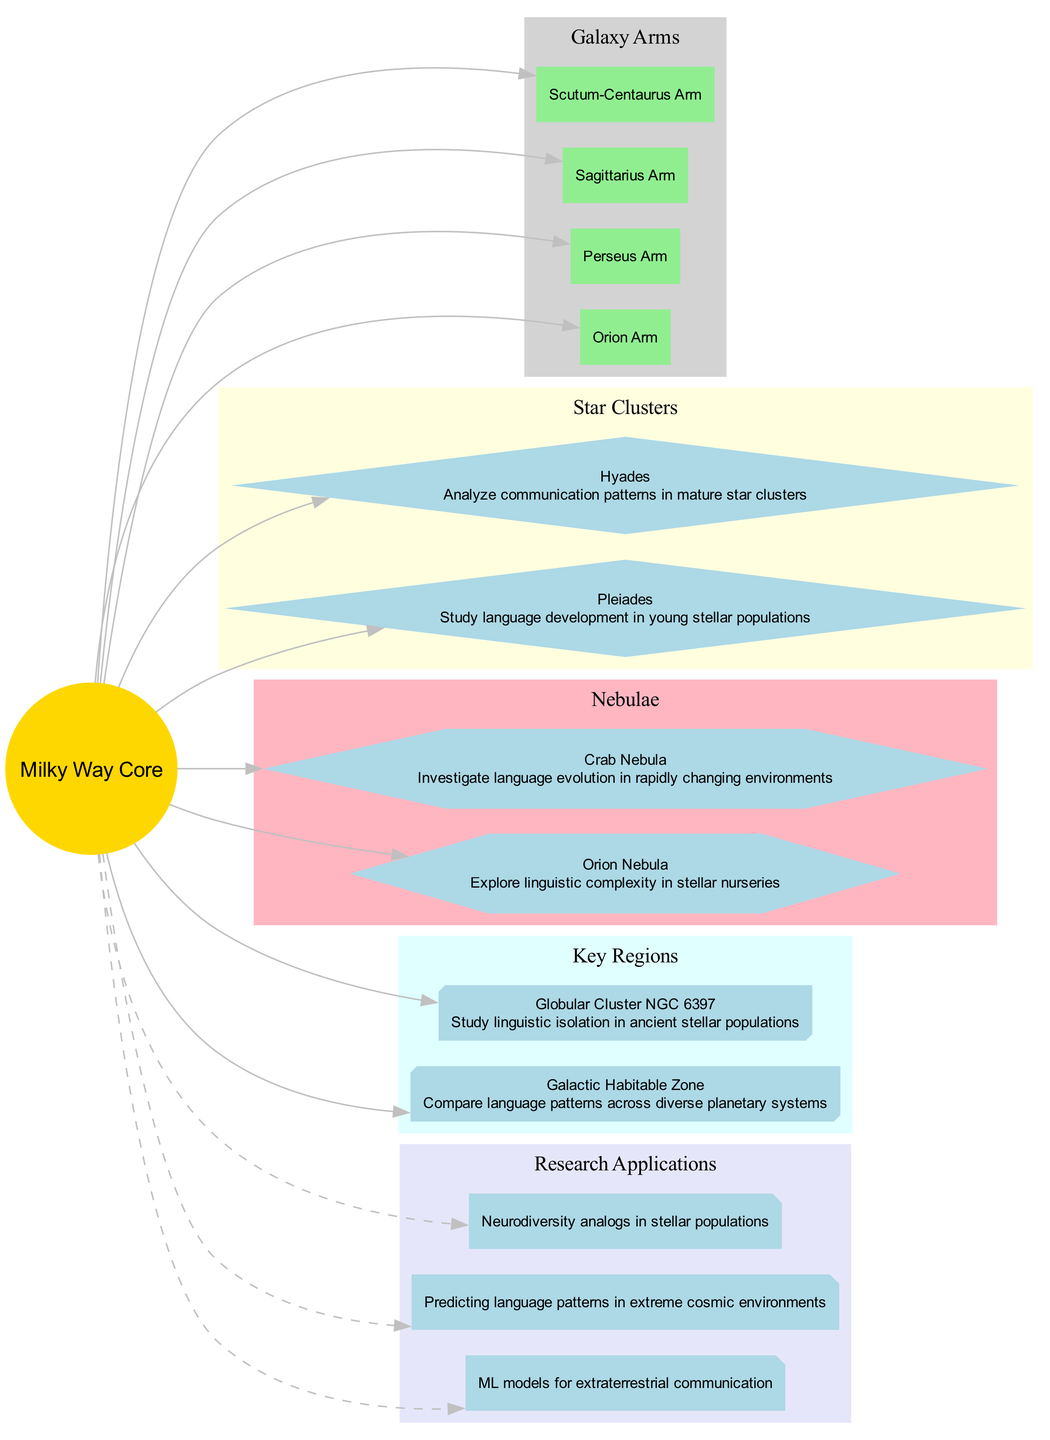What is the core of the Milky Way Galaxy? The core of the Milky Way Galaxy is labeled as "Milky Way Core" in the diagram, indicating it as the central part of the galaxy.
Answer: Milky Way Core How many star clusters are shown in the diagram? The diagram contains two star clusters: Pleiades and Hyades, which can be counted in the star clusters section.
Answer: 2 What major arm is labeled as "Orion Arm"? The label "Orion Arm" is mentioned in the arms section of the diagram, indicating its presence as one of the galaxy’s arms.
Answer: Orion Arm What is the annotation provided for the Orion Nebula? In the diagram, the Orion Nebula has the annotation "Explore linguistic complexity in stellar nurseries," which can be found next to its name.
Answer: Explore linguistic complexity in stellar nurseries Which key region is focused on linguistic isolation in ancient stellar populations? The key region named "Globular Cluster NGC 6397" in the diagram has the annotation addressing linguistic isolation in ancient stellar populations.
Answer: Globular Cluster NGC 6397 What research application involves ML models for extraterrestrial communication? The diagram includes the research application "ML models for extraterrestrial communication," which can be found in the research applications section.
Answer: ML models for extraterrestrial communication Which nebula is associated with language evolution in rapidly changing environments? The annotation next to the Crab Nebula states "Investigate language evolution in rapidly changing environments," indicating its specific research focus.
Answer: Investigate language evolution in rapidly changing environments What is annotated for the key region Galactic Habitable Zone? The Galactic Habitable Zone in the diagram is annotated with "Compare language patterns across diverse planetary systems," translating its implication for research purposes.
Answer: Compare language patterns across diverse planetary systems What type of star cluster is the Pleiades categorized as? The Pleiades is categorized as a "star cluster" in the diagram, specifically noted under the star clusters section.
Answer: star cluster 